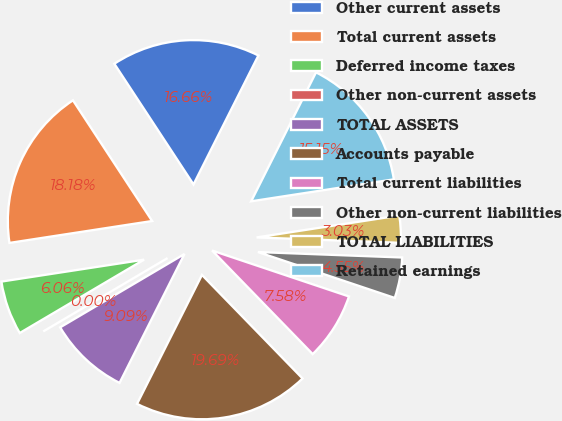Convert chart. <chart><loc_0><loc_0><loc_500><loc_500><pie_chart><fcel>Other current assets<fcel>Total current assets<fcel>Deferred income taxes<fcel>Other non-current assets<fcel>TOTAL ASSETS<fcel>Accounts payable<fcel>Total current liabilities<fcel>Other non-current liabilities<fcel>TOTAL LIABILITIES<fcel>Retained earnings<nl><fcel>16.66%<fcel>18.18%<fcel>6.06%<fcel>0.0%<fcel>9.09%<fcel>19.69%<fcel>7.58%<fcel>4.55%<fcel>3.03%<fcel>15.15%<nl></chart> 